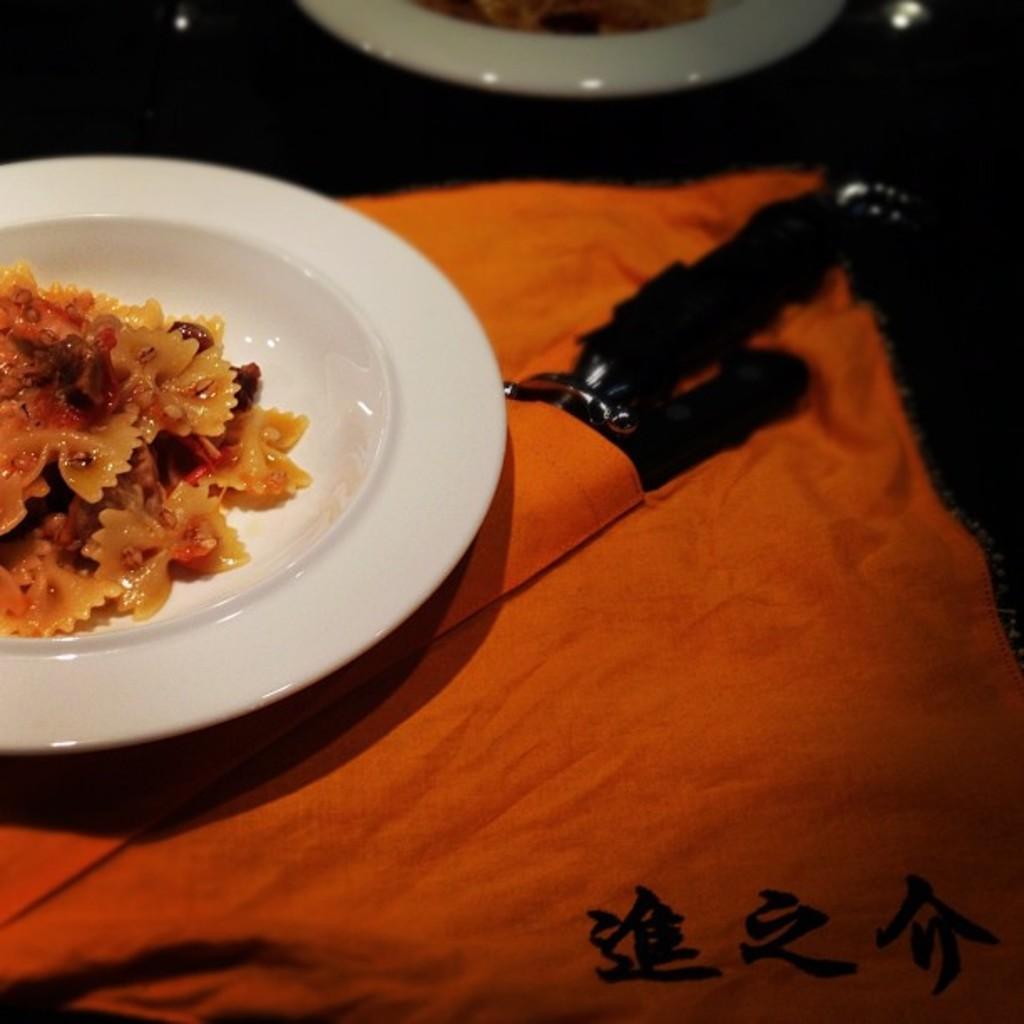In one or two sentences, can you explain what this image depicts? In this image we can see food item in a plate and an object are on the cloth. At the top we can see an item in a plate on a platform. 